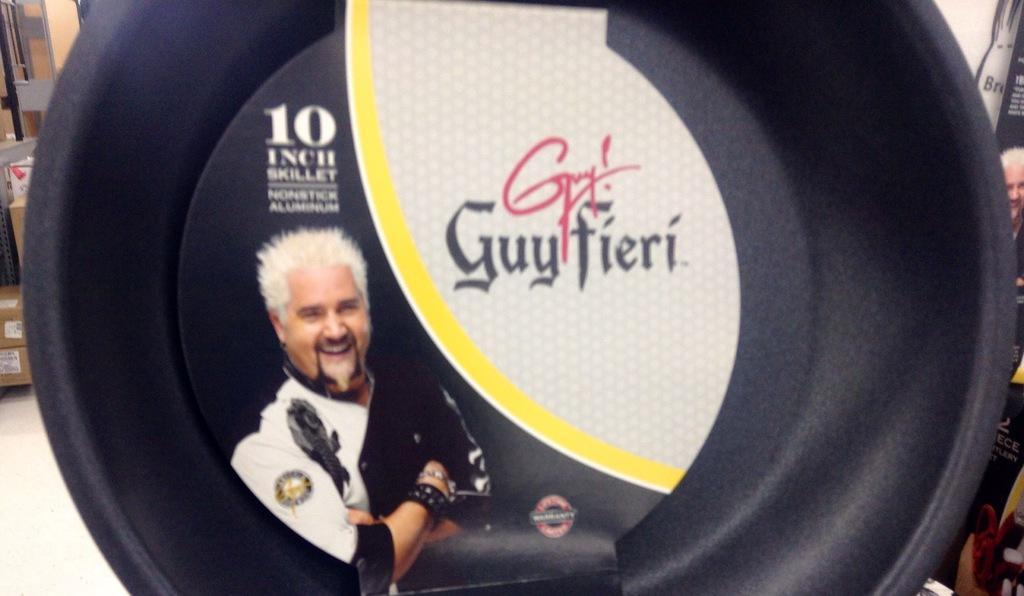How would you summarize this image in a sentence or two? In the picture we can see a black color object on which we can see a label on which we can see a person's image and some text. In the background, we can see some objects. 